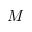<formula> <loc_0><loc_0><loc_500><loc_500>M</formula> 